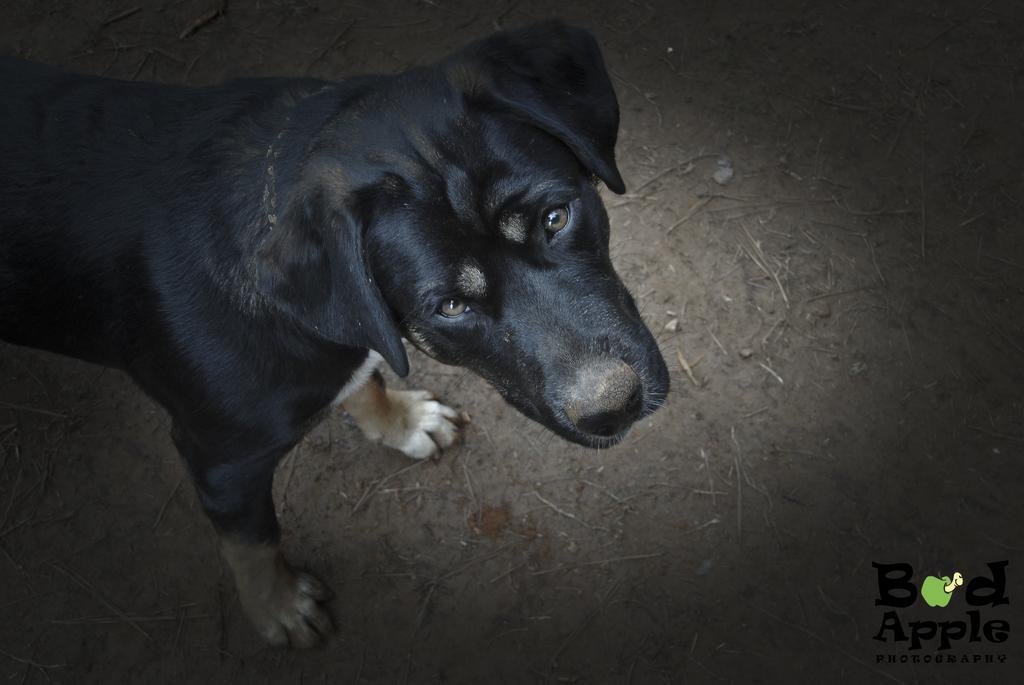In one or two sentences, can you explain what this image depicts? On the left side, there is a black color dog on the ground, on which there are small sticks. On the bottom right, there is a watermark. 